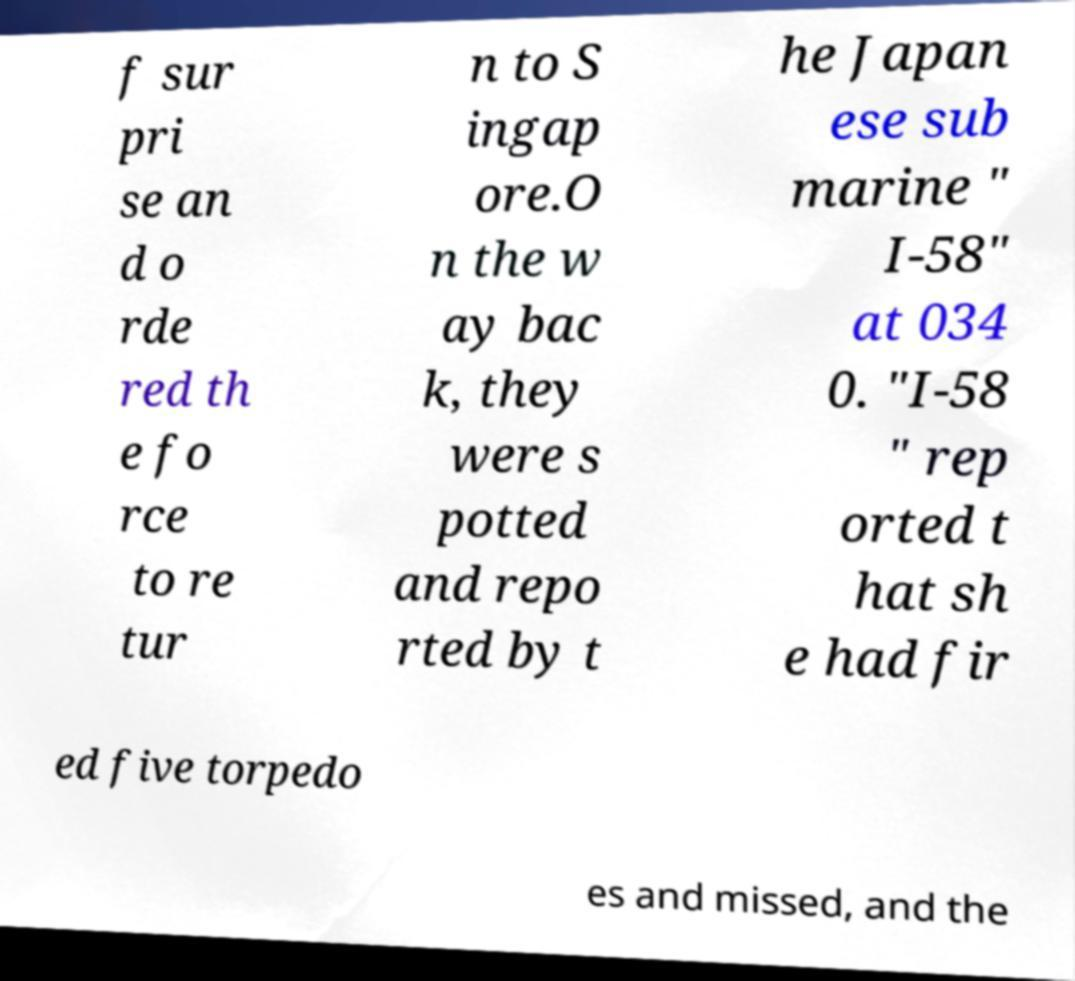What messages or text are displayed in this image? I need them in a readable, typed format. f sur pri se an d o rde red th e fo rce to re tur n to S ingap ore.O n the w ay bac k, they were s potted and repo rted by t he Japan ese sub marine " I-58" at 034 0. "I-58 " rep orted t hat sh e had fir ed five torpedo es and missed, and the 